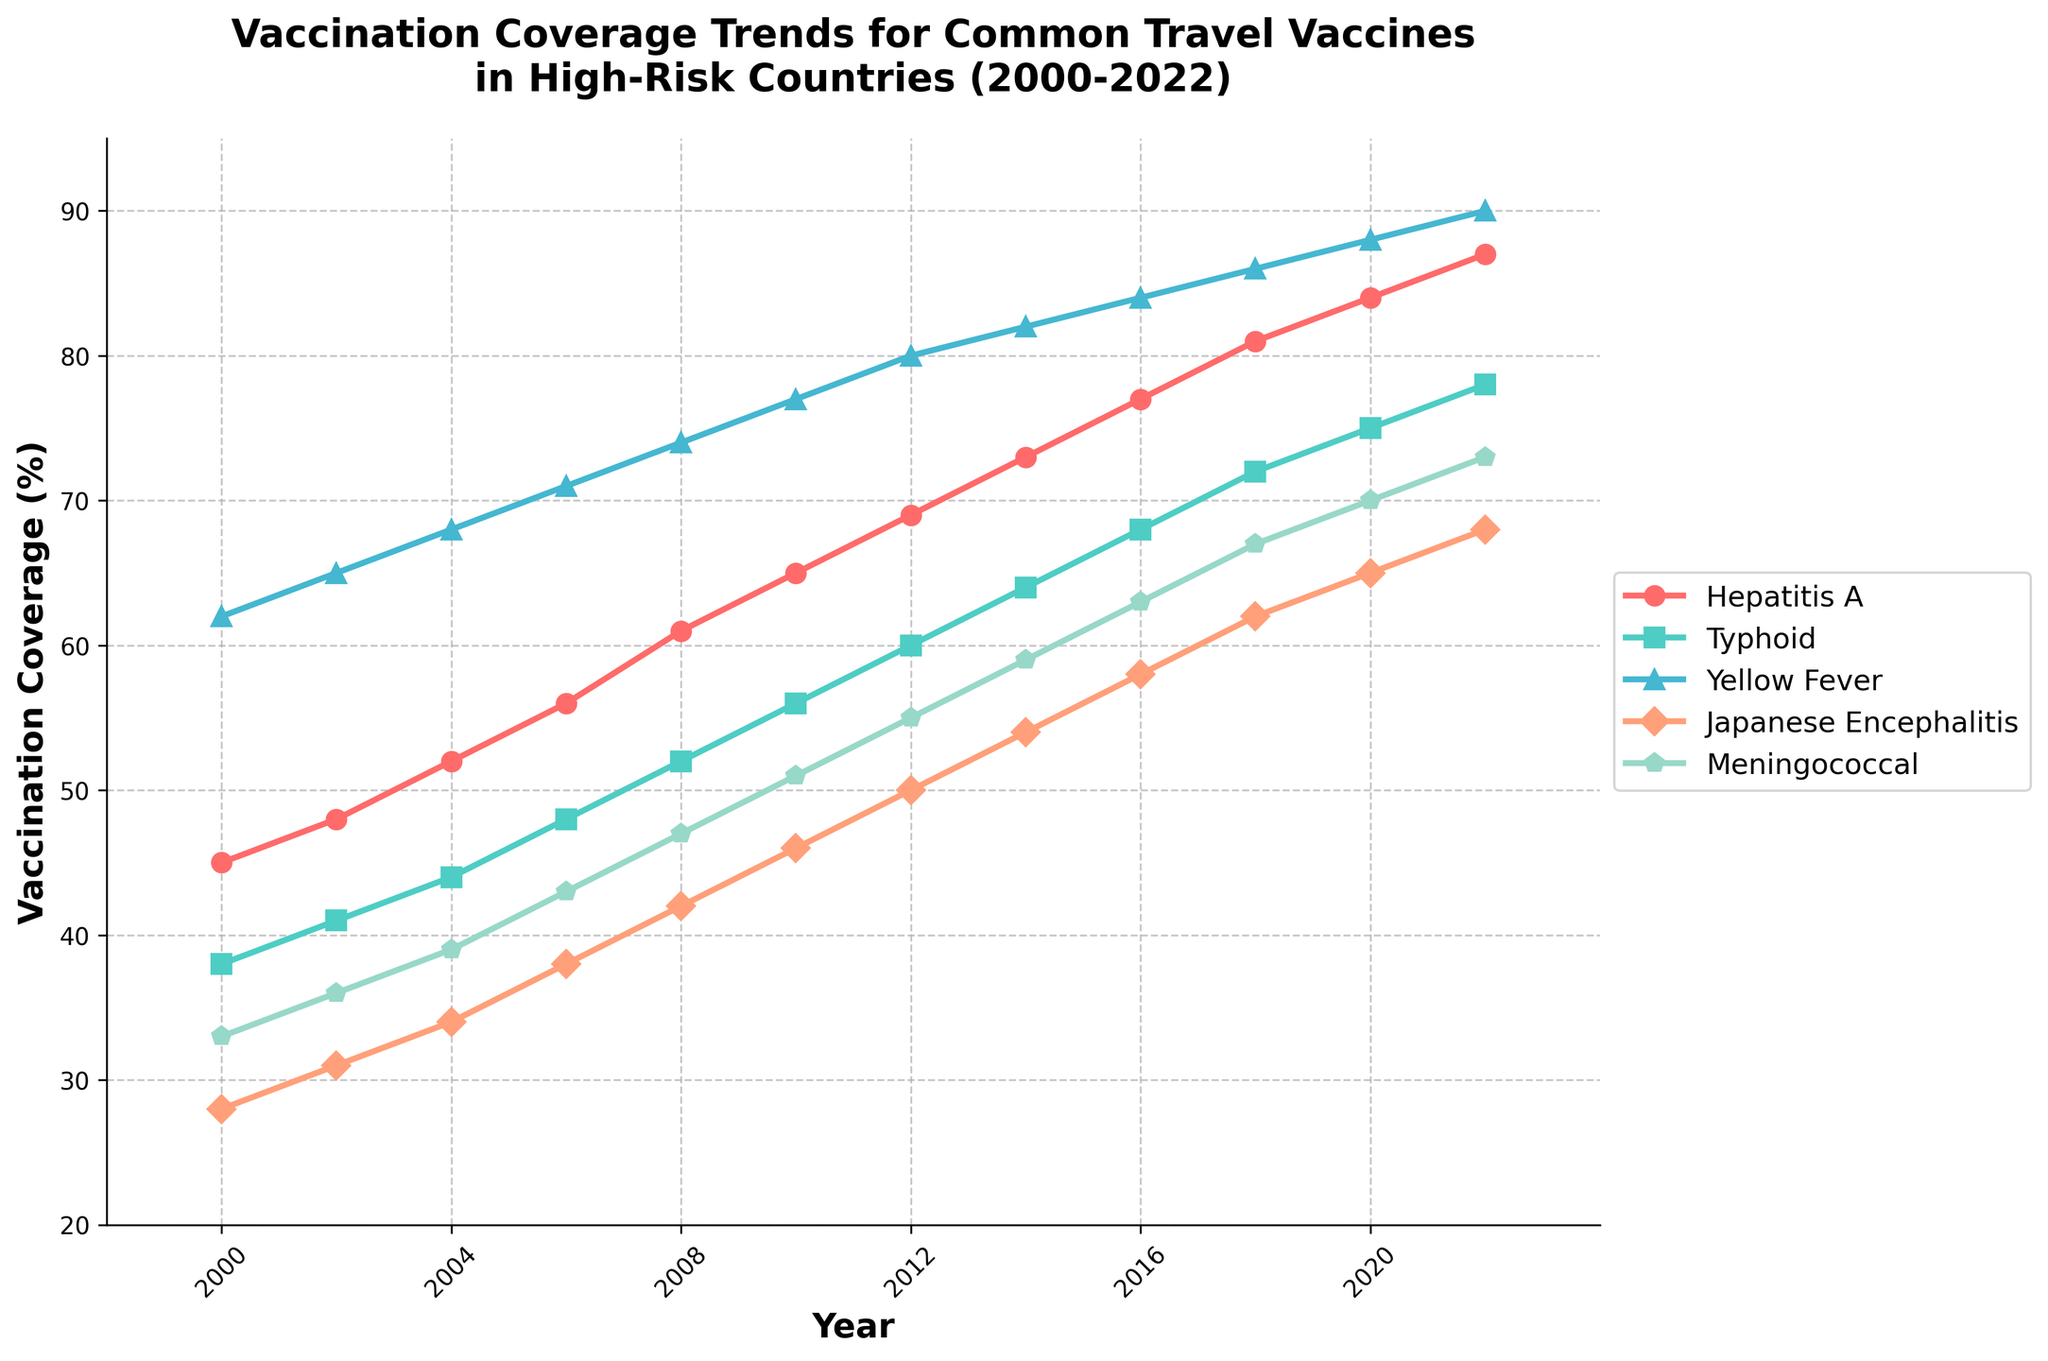what is the average vaccination coverage for Typhoid from 2000 to 2022? To calculate the average vaccination coverage for Typhoid, sum the values of each year and then divide by the number of years: (38 + 41 + 44 + 48 + 52 + 56 + 60 + 64 + 68 + 72 + 75 + 78) / 12 = 696 / 12 = 58
Answer: 58 Which vaccine shows the highest coverage in 2022? To find the highest coverage in 2022, compare the values for each vaccine in that year: Hepatitis A (87), Typhoid (78), Yellow Fever (90), Japanese Encephalitis (68), Meningococcal (73). The highest is Yellow Fever with 90%.
Answer: Yellow Fever Which years did Hepatitis A and Typhoid have the same vaccination coverage? Compare the coverage of Hepatitis A and Typhoid across all years. In 2000, 2002, 2004, and subsequent years, Hepatitis A and Typhoid never have the same value.
Answer: Never What is the increase in Hepatitis A coverage from 2000 to 2022? To find the increase, subtract the 2000 value from the 2022 value: 87 - 45 = 42.
Answer: 42 Which vaccine had the smallest increase in coverage from 2000 to 2022? Calculate the increase for each vaccine from 2000 to 2022: Hepatitis A (87-45=42), Typhoid (78-38=40), Yellow Fever (90-62=28), Japanese Encephalitis (68-28=40), Meningococcal (73-33=40). The smallest increase is for Yellow Fever with 28%.
Answer: Yellow Fever In which year did Meningococcal coverage reach 50% or higher for the first time? Check the values of Meningococcal coverage year by year and find the first one equal or higher than 50%. It reached 51% in 2010.
Answer: 2010 Between which two consecutive years did Japanese Encephalitis see the largest increase in coverage? Find the difference in Japanese Encephalitis coverage between consecutive years and see the largest increase: from 2000 to 2002 (31-28=3), from 2002 to 2004 (34-31=3), from 2004 to 2006 (38-34=4), from 2006 to 2008 (42-38=4), from 2008 to 2010 (46-42=4), from 2010 to 2012 (50-46=4), from 2012 to 2014 (54-50=4), from 2014 to 2016 (58-54=4), from 2016 to 2018 (62-58=4), from 2018 to 2020 (65-62=3), from 2020 to 2022 (68-65=3). The largest is 4 seen in multiple intervals, e.g., from 2004 to 2006.
Answer: 2004-2006 Which vaccine had the strongest trend of continuous growth without any decrease from 2000 to 2022? To determine the vaccine with continuous growth, observe each vaccine line: all vaccines seem to have continuous growth, none declining at any point.
Answer: All vaccines What is the combined coverage of all vaccines in 2010? Add the values of all vaccines in 2010: 65 (Hepatitis A) + 56 (Typhoid) + 77 (Yellow Fever) + 46 (Japanese Encephalitis) + 51 (Meningococcal) = 295.
Answer: 295 